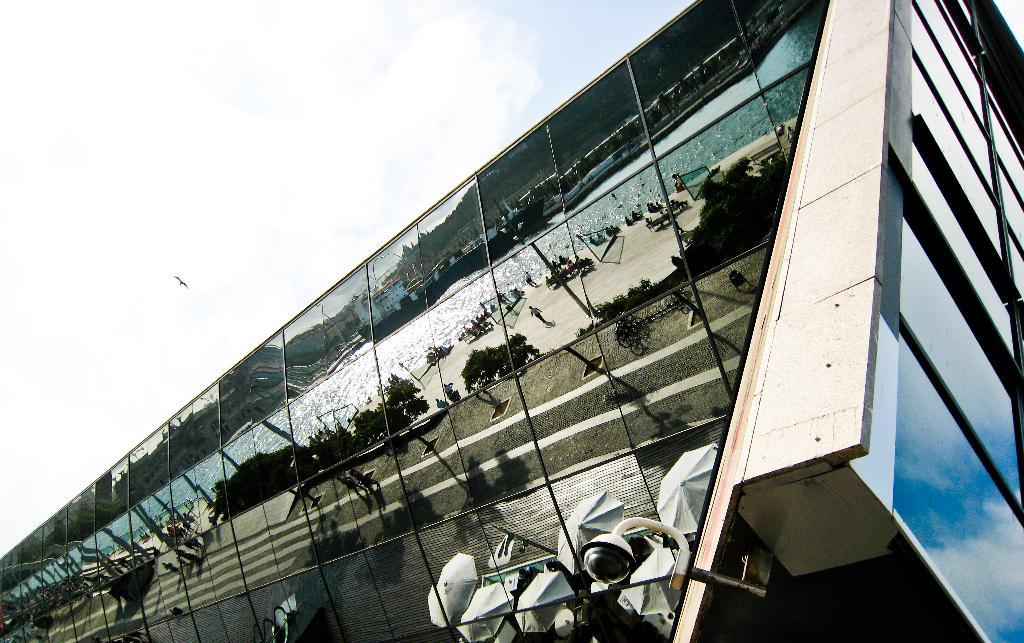What is the main structure in the image? There is a building in the image. Can you describe any additional features of the building? A security camera is attached to the building. What can be seen in the background of the image? There is a bird flying in the sky in the background of the image. What type of horn can be heard coming from the building in the image? There is no indication of any sound, including a horn, in the image. 